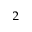<formula> <loc_0><loc_0><loc_500><loc_500>_ { 2 }</formula> 